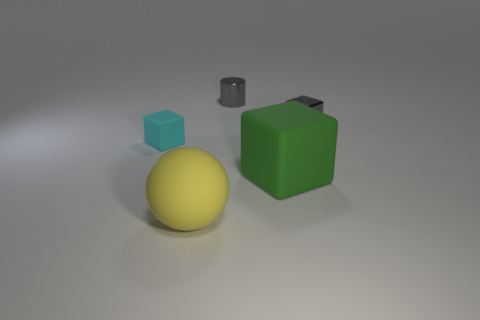Which object seems to have the smoothest surface? The object with the smoothest surface appears to be the yellow sphere due to its reflection and even curvature. 